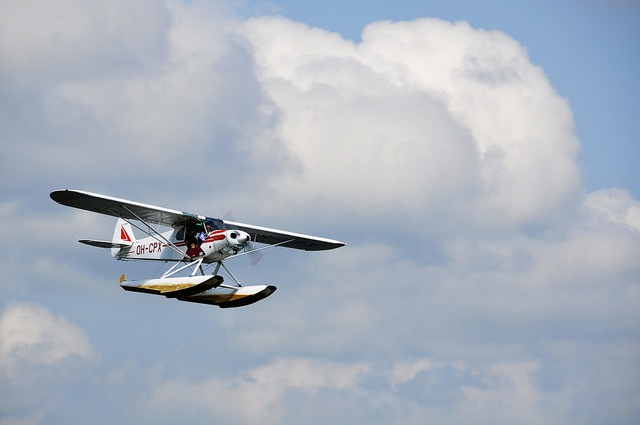Describe the objects in this image and their specific colors. I can see airplane in darkgray, black, lightgray, and gray tones and people in darkgray, black, gray, and lightgray tones in this image. 